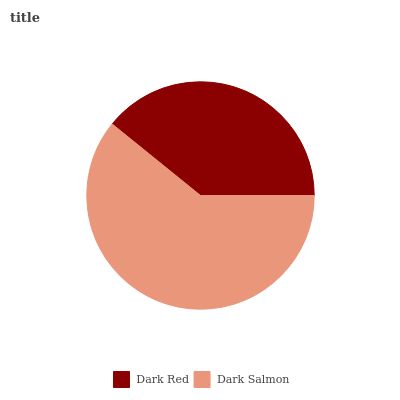Is Dark Red the minimum?
Answer yes or no. Yes. Is Dark Salmon the maximum?
Answer yes or no. Yes. Is Dark Salmon the minimum?
Answer yes or no. No. Is Dark Salmon greater than Dark Red?
Answer yes or no. Yes. Is Dark Red less than Dark Salmon?
Answer yes or no. Yes. Is Dark Red greater than Dark Salmon?
Answer yes or no. No. Is Dark Salmon less than Dark Red?
Answer yes or no. No. Is Dark Salmon the high median?
Answer yes or no. Yes. Is Dark Red the low median?
Answer yes or no. Yes. Is Dark Red the high median?
Answer yes or no. No. Is Dark Salmon the low median?
Answer yes or no. No. 